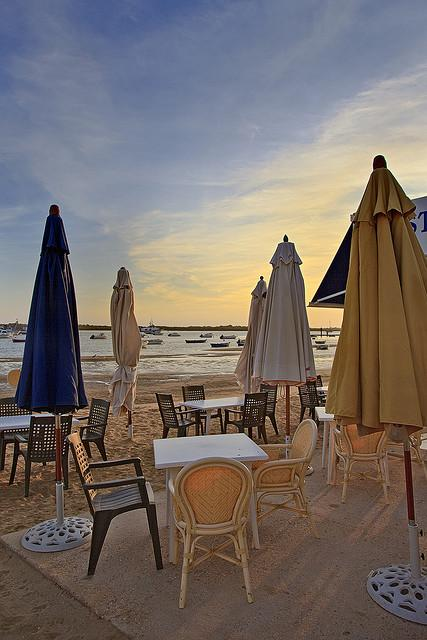What is near the table? Please explain your reasoning. chair. There are no humans or animals near the table. 